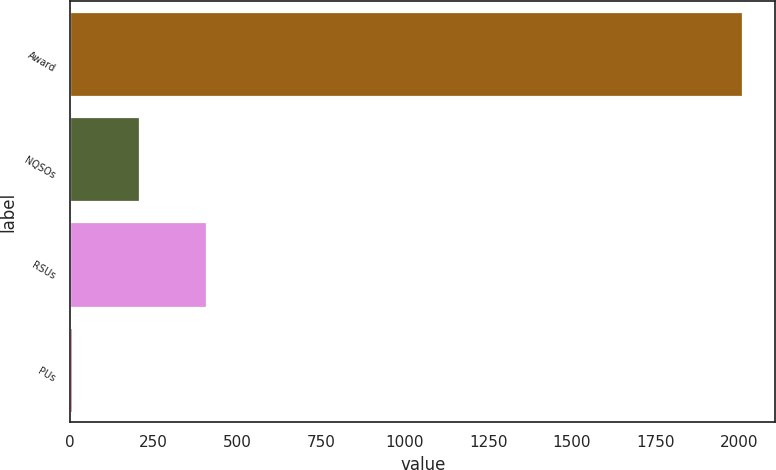<chart> <loc_0><loc_0><loc_500><loc_500><bar_chart><fcel>Award<fcel>NQSOs<fcel>RSUs<fcel>PUs<nl><fcel>2008<fcel>205.3<fcel>405.6<fcel>5<nl></chart> 